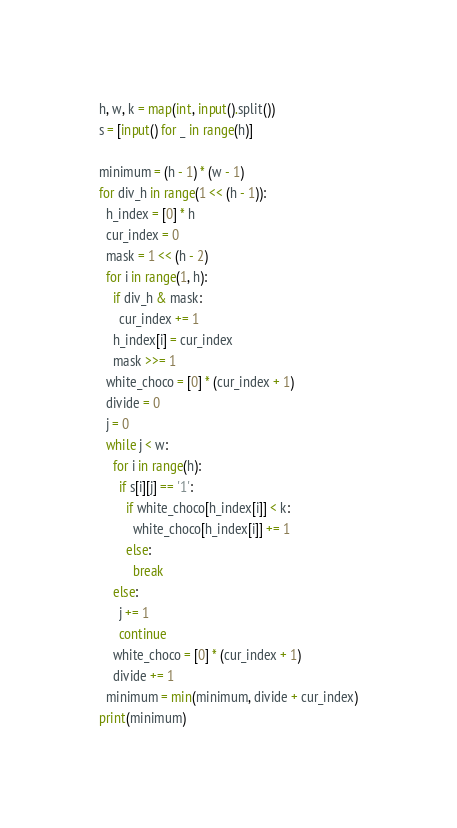Convert code to text. <code><loc_0><loc_0><loc_500><loc_500><_Python_>h, w, k = map(int, input().split())
s = [input() for _ in range(h)]

minimum = (h - 1) * (w - 1)
for div_h in range(1 << (h - 1)):
  h_index = [0] * h
  cur_index = 0
  mask = 1 << (h - 2)
  for i in range(1, h):
    if div_h & mask:
      cur_index += 1
    h_index[i] = cur_index
    mask >>= 1
  white_choco = [0] * (cur_index + 1)
  divide = 0
  j = 0
  while j < w:
    for i in range(h):
      if s[i][j] == '1':
        if white_choco[h_index[i]] < k:
          white_choco[h_index[i]] += 1
        else:
          break
    else:
      j += 1
      continue
    white_choco = [0] * (cur_index + 1)
    divide += 1
  minimum = min(minimum, divide + cur_index)
print(minimum)</code> 